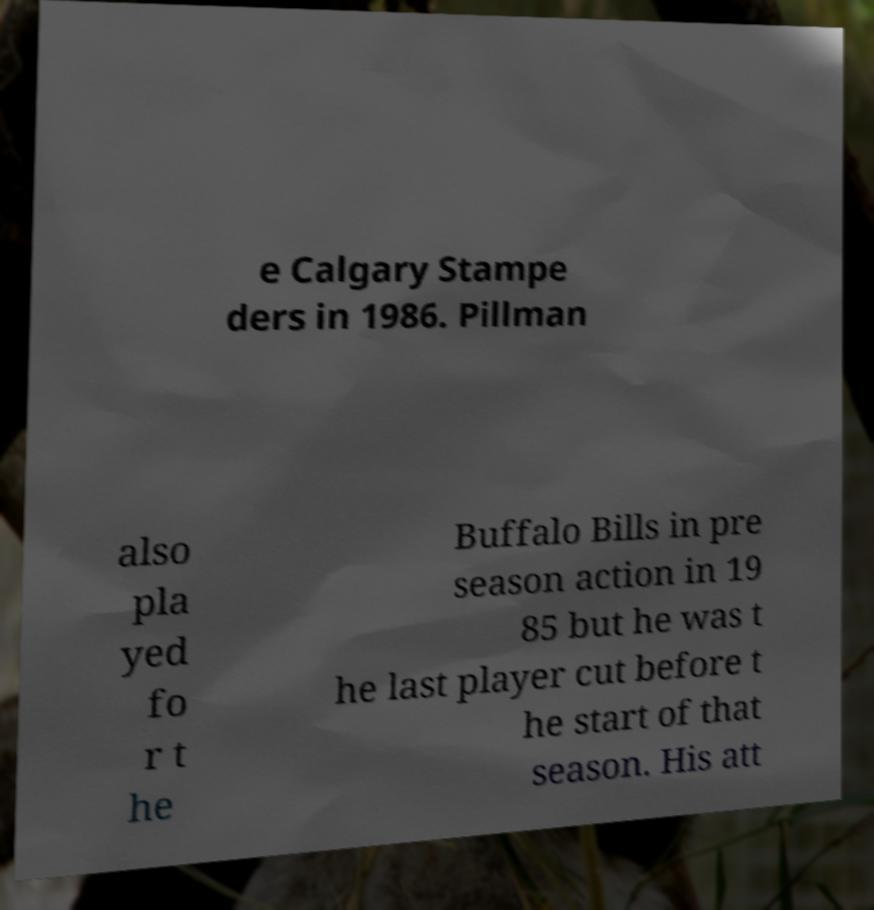I need the written content from this picture converted into text. Can you do that? e Calgary Stampe ders in 1986. Pillman also pla yed fo r t he Buffalo Bills in pre season action in 19 85 but he was t he last player cut before t he start of that season. His att 